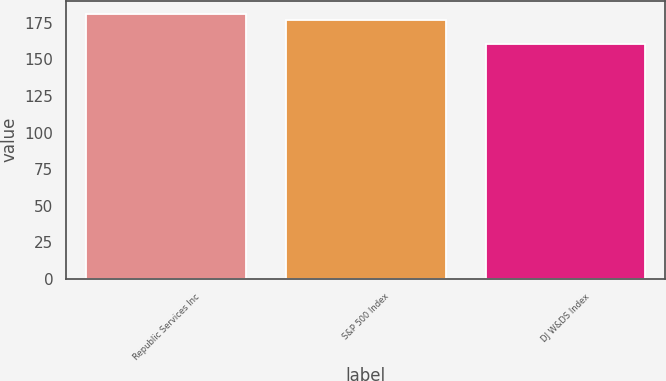Convert chart. <chart><loc_0><loc_0><loc_500><loc_500><bar_chart><fcel>Republic Services Inc<fcel>S&P 500 Index<fcel>DJ W&DS Index<nl><fcel>181.21<fcel>177.01<fcel>160.66<nl></chart> 